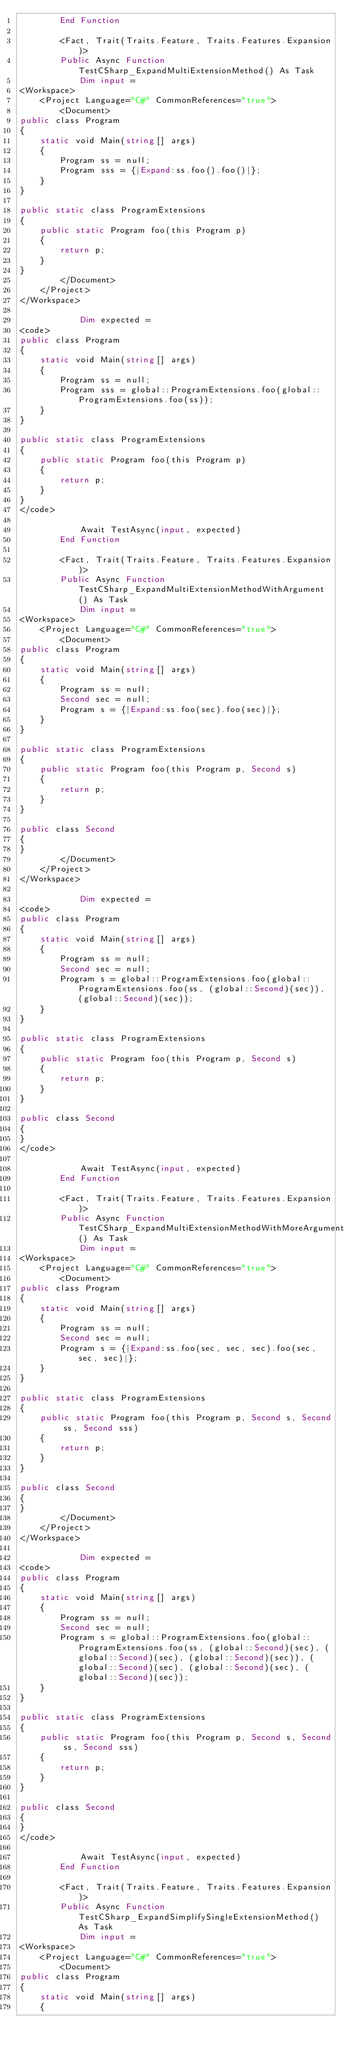Convert code to text. <code><loc_0><loc_0><loc_500><loc_500><_VisualBasic_>        End Function

        <Fact, Trait(Traits.Feature, Traits.Features.Expansion)>
        Public Async Function TestCSharp_ExpandMultiExtensionMethod() As Task
            Dim input =
<Workspace>
    <Project Language="C#" CommonReferences="true">
        <Document>
public class Program
{
    static void Main(string[] args)
    {
        Program ss = null;
        Program sss = {|Expand:ss.foo().foo()|};
    }
}

public static class ProgramExtensions
{
    public static Program foo(this Program p)
    {
        return p;
    }
}
        </Document>
    </Project>
</Workspace>

            Dim expected =
<code>
public class Program
{
    static void Main(string[] args)
    {
        Program ss = null;
        Program sss = global::ProgramExtensions.foo(global::ProgramExtensions.foo(ss));
    }
}

public static class ProgramExtensions
{
    public static Program foo(this Program p)
    {
        return p;
    }
}
</code>

            Await TestAsync(input, expected)
        End Function

        <Fact, Trait(Traits.Feature, Traits.Features.Expansion)>
        Public Async Function TestCSharp_ExpandMultiExtensionMethodWithArgument() As Task
            Dim input =
<Workspace>
    <Project Language="C#" CommonReferences="true">
        <Document>
public class Program
{
    static void Main(string[] args)
    {
        Program ss = null;
        Second sec = null;
        Program s = {|Expand:ss.foo(sec).foo(sec)|};
    }
}

public static class ProgramExtensions
{
    public static Program foo(this Program p, Second s)
    {
        return p;
    }
}

public class Second
{
}
        </Document>
    </Project>
</Workspace>

            Dim expected =
<code>
public class Program
{
    static void Main(string[] args)
    {
        Program ss = null;
        Second sec = null;
        Program s = global::ProgramExtensions.foo(global::ProgramExtensions.foo(ss, (global::Second)(sec)), (global::Second)(sec));
    }
}

public static class ProgramExtensions
{
    public static Program foo(this Program p, Second s)
    {
        return p;
    }
}

public class Second
{
}
</code>

            Await TestAsync(input, expected)
        End Function

        <Fact, Trait(Traits.Feature, Traits.Features.Expansion)>
        Public Async Function TestCSharp_ExpandMultiExtensionMethodWithMoreArgument() As Task
            Dim input =
<Workspace>
    <Project Language="C#" CommonReferences="true">
        <Document>
public class Program
{
    static void Main(string[] args)
    {
        Program ss = null;
        Second sec = null;
        Program s = {|Expand:ss.foo(sec, sec, sec).foo(sec, sec, sec)|};
    }
}

public static class ProgramExtensions
{
    public static Program foo(this Program p, Second s, Second ss, Second sss)
    {
        return p;
    }
}

public class Second
{
}
        </Document>
    </Project>
</Workspace>

            Dim expected =
<code>
public class Program
{
    static void Main(string[] args)
    {
        Program ss = null;
        Second sec = null;
        Program s = global::ProgramExtensions.foo(global::ProgramExtensions.foo(ss, (global::Second)(sec), (global::Second)(sec), (global::Second)(sec)), (global::Second)(sec), (global::Second)(sec), (global::Second)(sec));
    }
}

public static class ProgramExtensions
{
    public static Program foo(this Program p, Second s, Second ss, Second sss)
    {
        return p;
    }
}

public class Second
{
}
</code>

            Await TestAsync(input, expected)
        End Function

        <Fact, Trait(Traits.Feature, Traits.Features.Expansion)>
        Public Async Function TestCSharp_ExpandSimplifySingleExtensionMethod() As Task
            Dim input =
<Workspace>
    <Project Language="C#" CommonReferences="true">
        <Document>
public class Program
{
    static void Main(string[] args)
    {</code> 